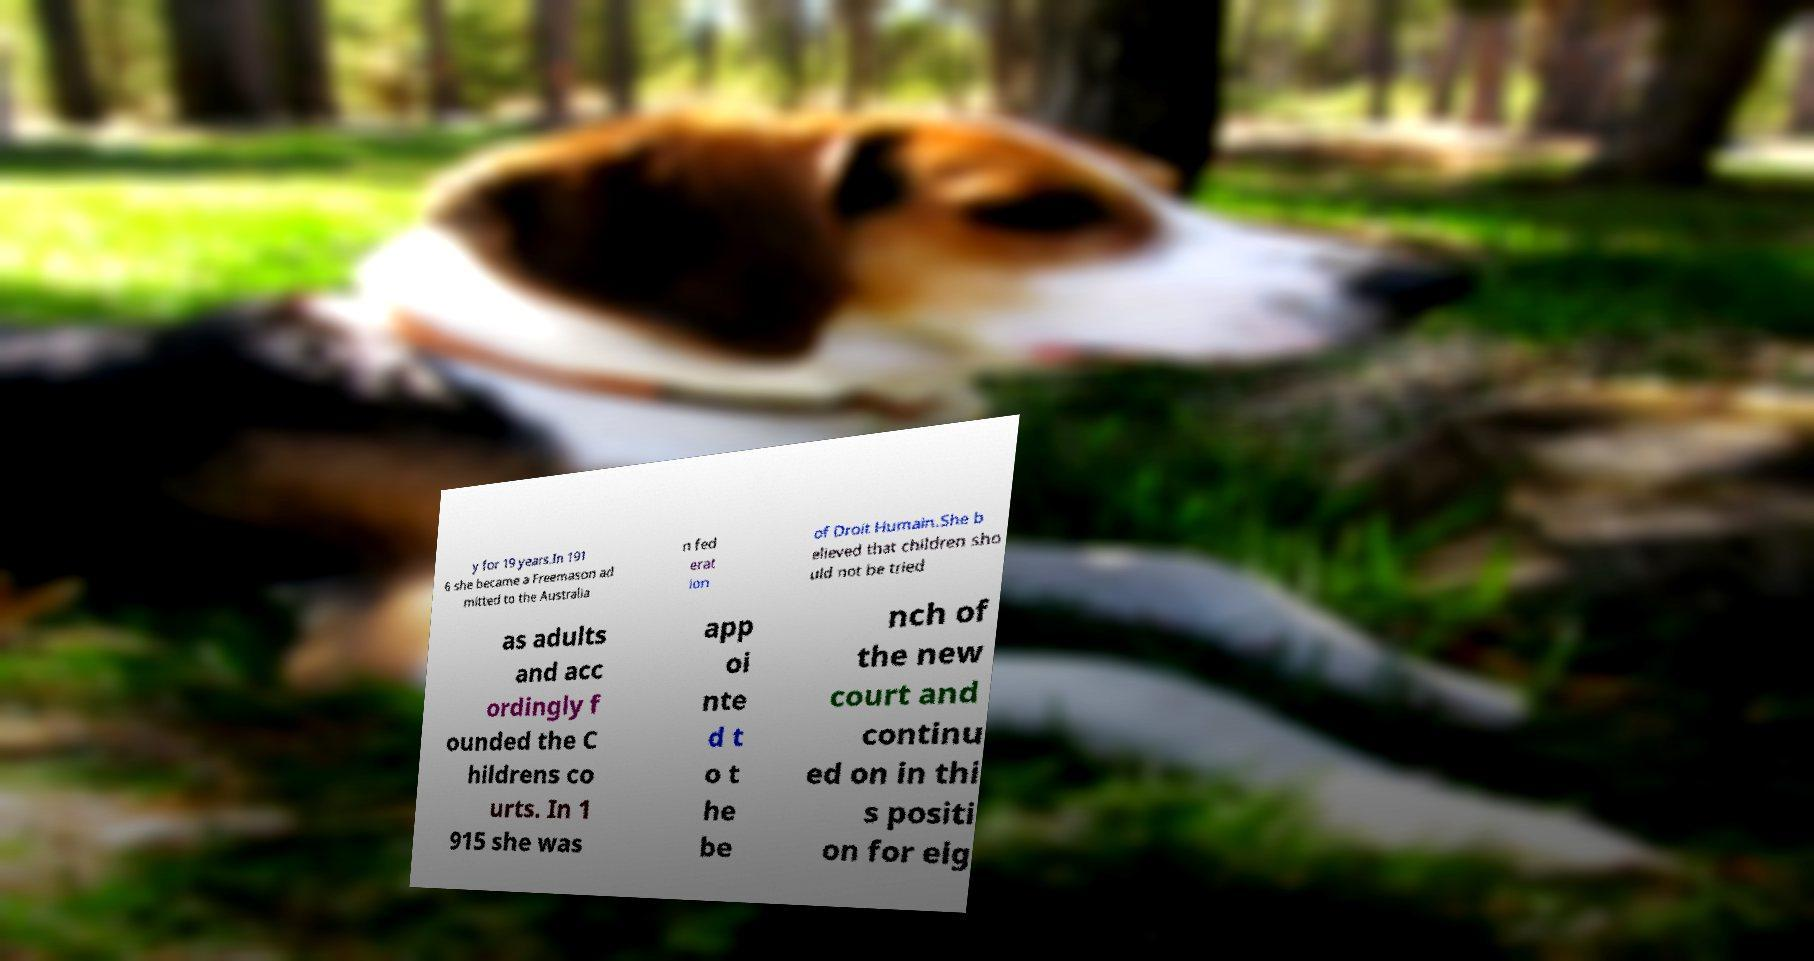I need the written content from this picture converted into text. Can you do that? y for 19 years.In 191 6 she became a Freemason ad mitted to the Australia n fed erat ion of Droit Humain.She b elieved that children sho uld not be tried as adults and acc ordingly f ounded the C hildrens co urts. In 1 915 she was app oi nte d t o t he be nch of the new court and continu ed on in thi s positi on for eig 